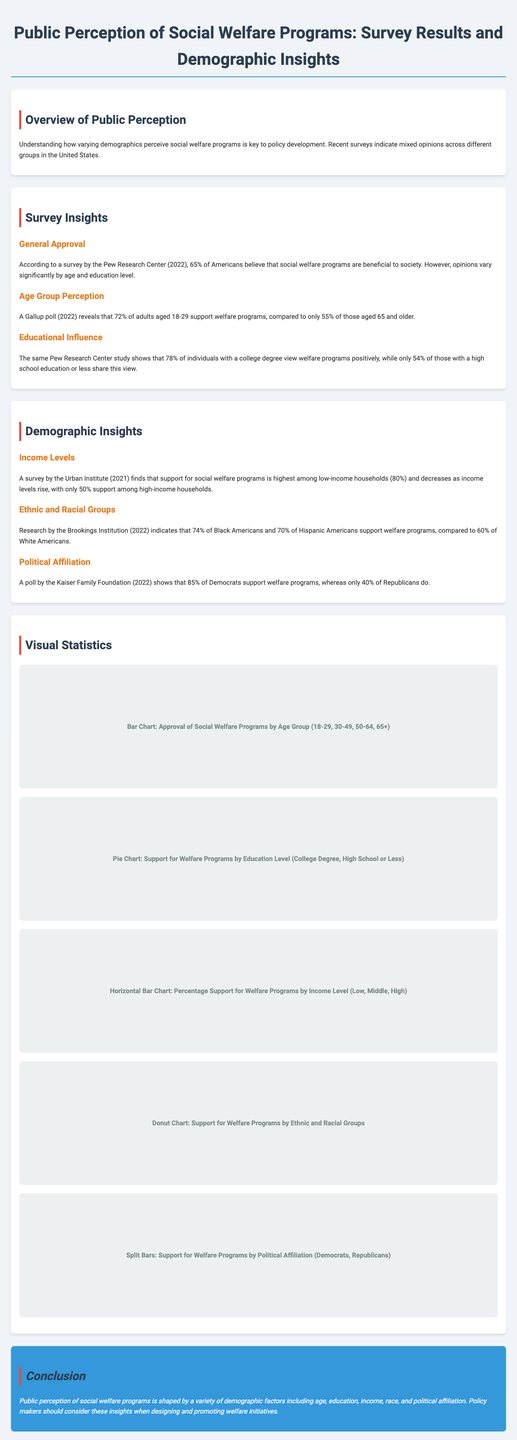what percentage of Americans believe social welfare programs are beneficial? The document states that according to a survey by the Pew Research Center in 2022, 65% of Americans believe that social welfare programs are beneficial to society.
Answer: 65% what is the approval percentage of welfare programs among adults aged 18-29? A Gallup poll in 2022 reveals that 72% of adults aged 18-29 support welfare programs.
Answer: 72% how many percent of individuals with a college degree view welfare programs positively? The Pew Research Center study shows that 78% of individuals with a college degree view welfare programs positively.
Answer: 78% what is the support percentage for welfare programs among low-income households? A survey by the Urban Institute (2021) finds that support for social welfare programs is highest among low-income households at 80%.
Answer: 80% which racial group has the highest support for welfare programs according to the Brookings Institution? The research indicates that 74% of Black Americans support welfare programs, which is the highest among the racial groups mentioned.
Answer: Black Americans what percentage of Democrats support welfare programs? A poll by the Kaiser Family Foundation (2022) shows that 85% of Democrats support welfare programs.
Answer: 85% which educational group shows the lowest support for welfare programs? The document states that only 54% of those with a high school education or less share a positive view of welfare programs.
Answer: High School or Less what conclusion can be drawn about public perception of social welfare programs? The conclusion in the document indicates that public perception is shaped by various demographic factors including age, education, income, race, and political affiliation.
Answer: Demographic factors what visual representation illustrates the support for welfare programs by income level? The document describes a horizontal bar chart illustrating the percentage support for welfare programs by income level.
Answer: Horizontal Bar Chart 